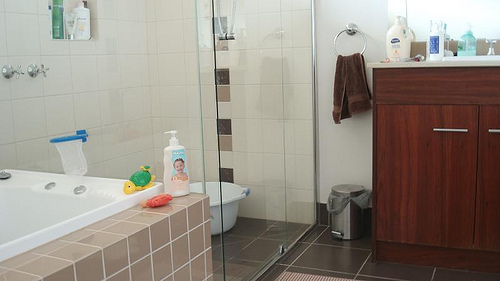Can you describe what you see in this image? The image shows a well-kept bathroom with a bathtub, a shower area, and a bathroom counter. Various toiletry items and containers are scattered around, along with some toys near the tub. 